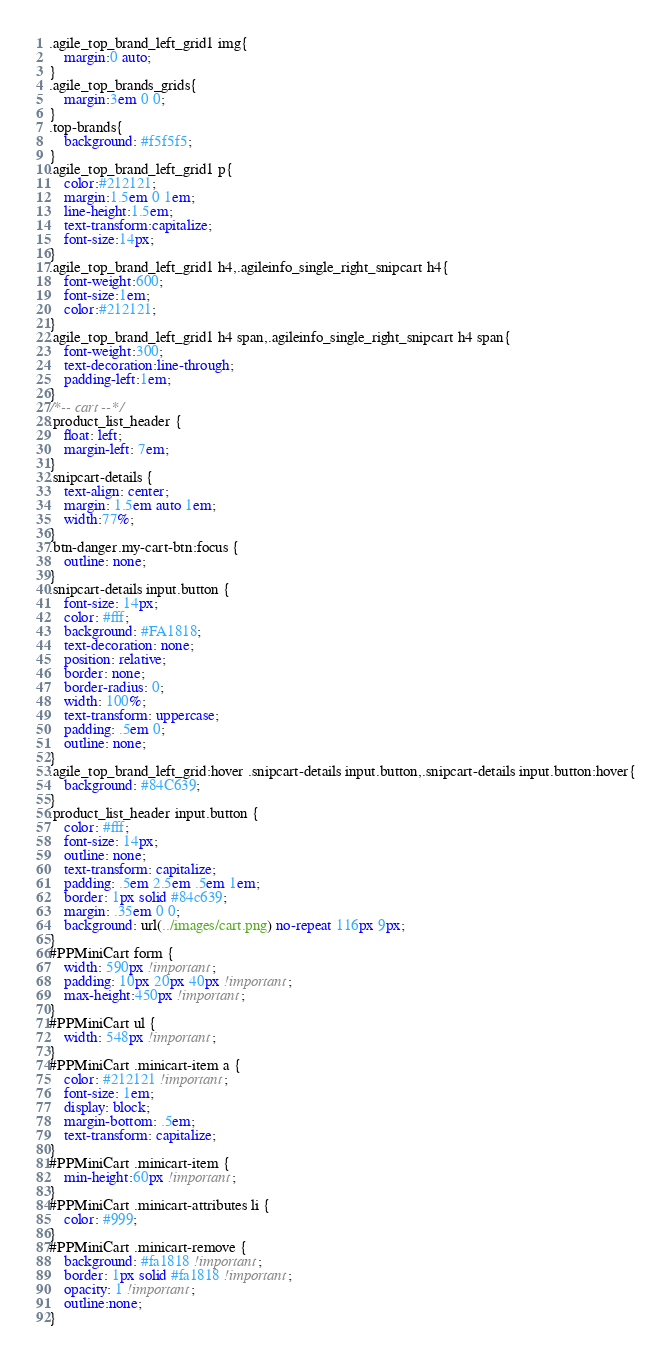<code> <loc_0><loc_0><loc_500><loc_500><_CSS_>.agile_top_brand_left_grid1 img{
	margin:0 auto;
}
.agile_top_brands_grids{
	margin:3em 0 0;
}
.top-brands{
    background: #f5f5f5;
}
.agile_top_brand_left_grid1 p{
	color:#212121;
	margin:1.5em 0 1em;
	line-height:1.5em;
	text-transform:capitalize;
	font-size:14px;
}
.agile_top_brand_left_grid1 h4,.agileinfo_single_right_snipcart h4{
	font-weight:600;
	font-size:1em;
	color:#212121;
}
.agile_top_brand_left_grid1 h4 span,.agileinfo_single_right_snipcart h4 span{
	font-weight:300;
	text-decoration:line-through;
	padding-left:1em;
}
/*-- cart --*/
.product_list_header {
    float: left;
    margin-left: 7em;
}
.snipcart-details {
    text-align: center;
	margin: 1.5em auto 1em;
    width:77%;
}
.btn-danger.my-cart-btn:focus {
    outline: none;
}
.snipcart-details input.button {
    font-size: 14px;
    color: #fff;
    background: #FA1818;
    text-decoration: none;
    position: relative;
    border: none;
    border-radius: 0;
    width: 100%;
    text-transform: uppercase;
    padding: .5em 0;
    outline: none;
}
.agile_top_brand_left_grid:hover .snipcart-details input.button,.snipcart-details input.button:hover{
    background: #84C639;
}
.product_list_header input.button {
    color: #fff;
    font-size: 14px;
    outline: none;
    text-transform: capitalize;
    padding: .5em 2.5em .5em 1em;
    border: 1px solid #84c639;
    margin: .35em 0 0;
    background: url(../images/cart.png) no-repeat 116px 9px;
}
#PPMiniCart form {
    width: 590px !important;
	padding: 10px 20px 40px !important;
	max-height:450px !important;
}
#PPMiniCart ul {
    width: 548px !important;
}
#PPMiniCart .minicart-item a {
    color: #212121 !important;
    font-size: 1em;
    display: block;
    margin-bottom: .5em;
    text-transform: capitalize;
}
#PPMiniCart .minicart-item {
    min-height:60px !important;
}
#PPMiniCart .minicart-attributes li {
    color: #999;
}
#PPMiniCart .minicart-remove {
    background: #fa1818 !important;
    border: 1px solid #fa1818 !important;
	opacity: 1 !important;
	outline:none;
}</code> 